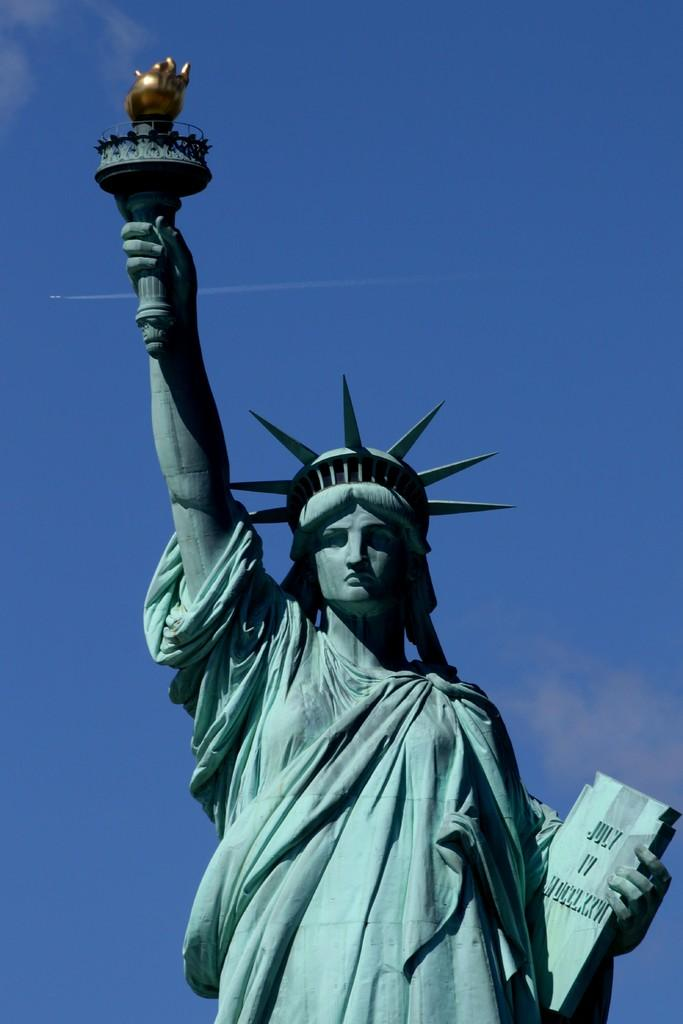Where was the image taken? The image is taken outdoors. What is the main subject of the image? There is a statue of liberty in the image. What is the statue of liberty holding in each hand? The statue of liberty is holding a book and a fire stick. What can be seen in the background of the image? The sky is visible in the background of the image. What is the weather like in the image? Clouds are present in the sky, suggesting a partly cloudy day. What type of crook is trying to steal the statue of liberty in the image? There is no crook or theft depicted in the image; it features a statue of liberty holding a book and a fire stick. What error can be seen in the image? There is no error present in the image; it accurately depicts a statue of liberty holding a book and a fire stick. 